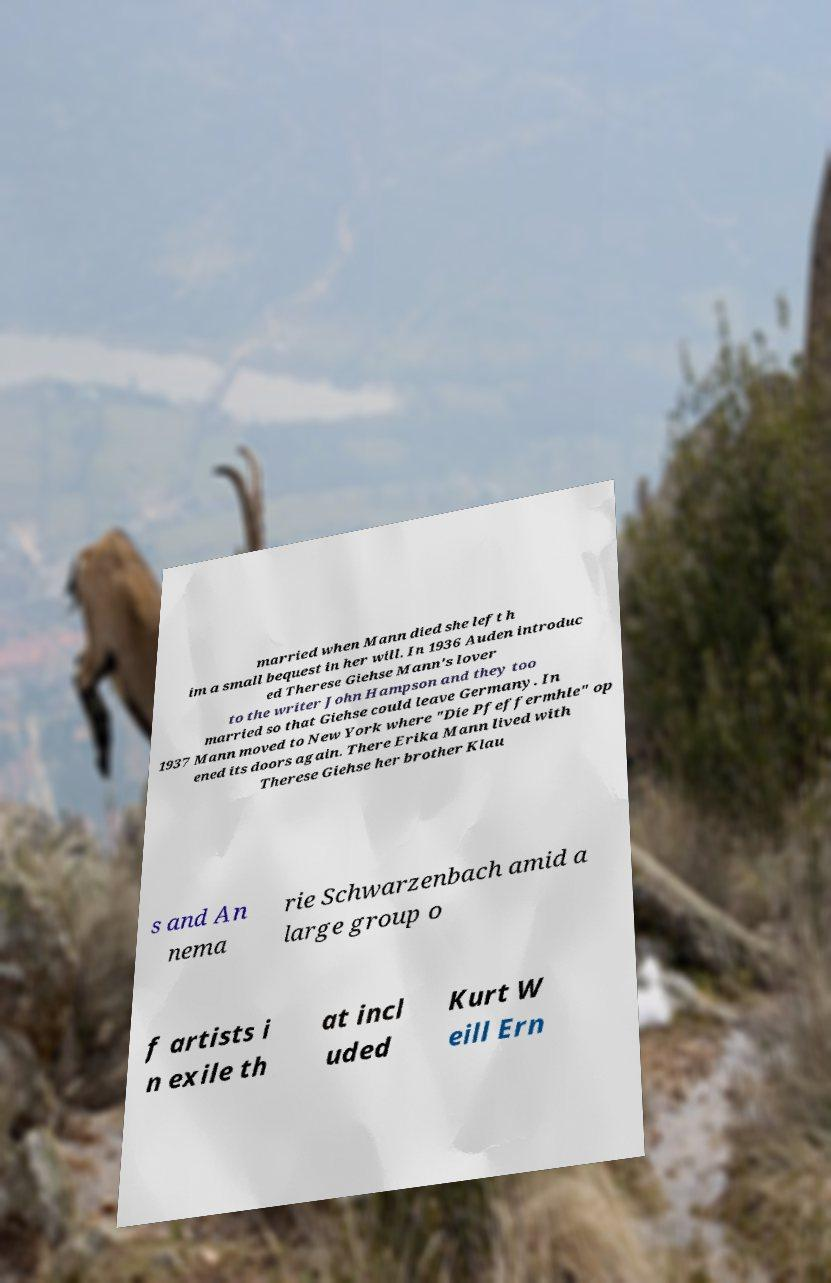I need the written content from this picture converted into text. Can you do that? married when Mann died she left h im a small bequest in her will. In 1936 Auden introduc ed Therese Giehse Mann's lover to the writer John Hampson and they too married so that Giehse could leave Germany. In 1937 Mann moved to New York where "Die Pfeffermhle" op ened its doors again. There Erika Mann lived with Therese Giehse her brother Klau s and An nema rie Schwarzenbach amid a large group o f artists i n exile th at incl uded Kurt W eill Ern 